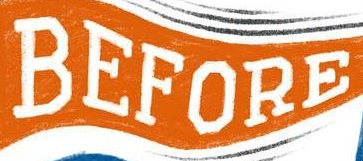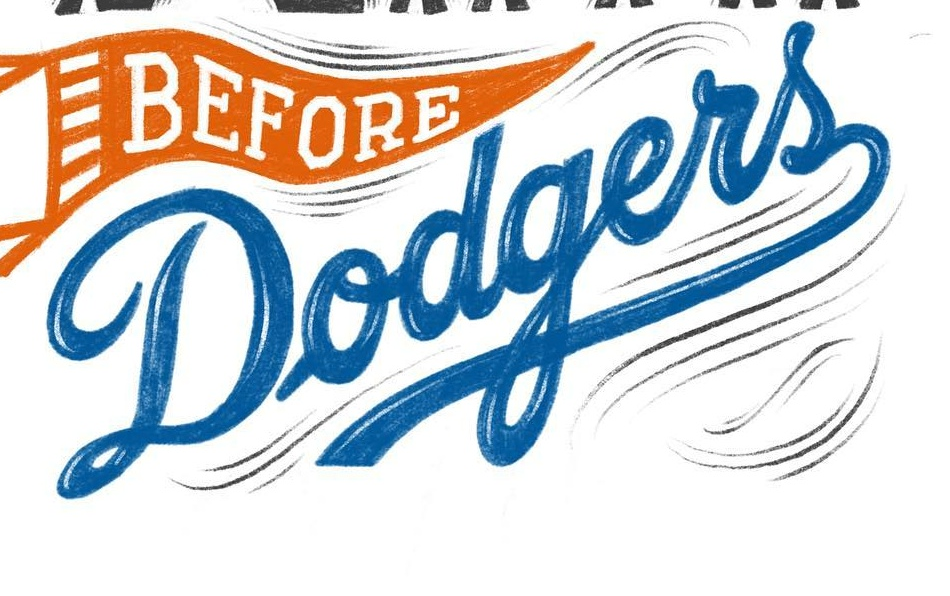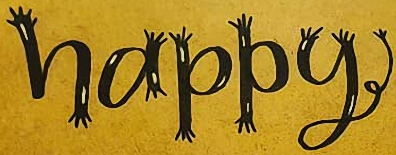What text is displayed in these images sequentially, separated by a semicolon? BEFORE; Dodgers; happy 